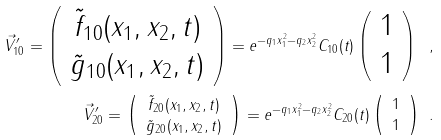Convert formula to latex. <formula><loc_0><loc_0><loc_500><loc_500>\vec { V } ^ { \prime } _ { 1 0 } = \left ( \begin{array} { c } \tilde { f } _ { 1 0 } ( x _ { 1 } , x _ { 2 } , t ) \\ \tilde { g } _ { 1 0 } ( x _ { 1 } , x _ { 2 } , t ) \end{array} \right ) = e ^ { - q _ { 1 } x _ { 1 } ^ { 2 } - q _ { 2 } x _ { 2 } ^ { 2 } } C _ { 1 0 } ( t ) \left ( \begin{array} { c } 1 \\ 1 \end{array} \right ) \ , \\ \vec { V } ^ { \prime } _ { 2 0 } = \left ( \begin{array} { c } \tilde { f } _ { 2 0 } ( x _ { 1 } , x _ { 2 } , t ) \\ \tilde { g } _ { 2 0 } ( x _ { 1 } , x _ { 2 } , t ) \end{array} \right ) = e ^ { - q _ { 1 } x _ { 1 } ^ { 2 } - q _ { 2 } x _ { 2 } ^ { 2 } } C _ { 2 0 } ( t ) \left ( \begin{array} { c } 1 \\ 1 \end{array} \right ) \ .</formula> 